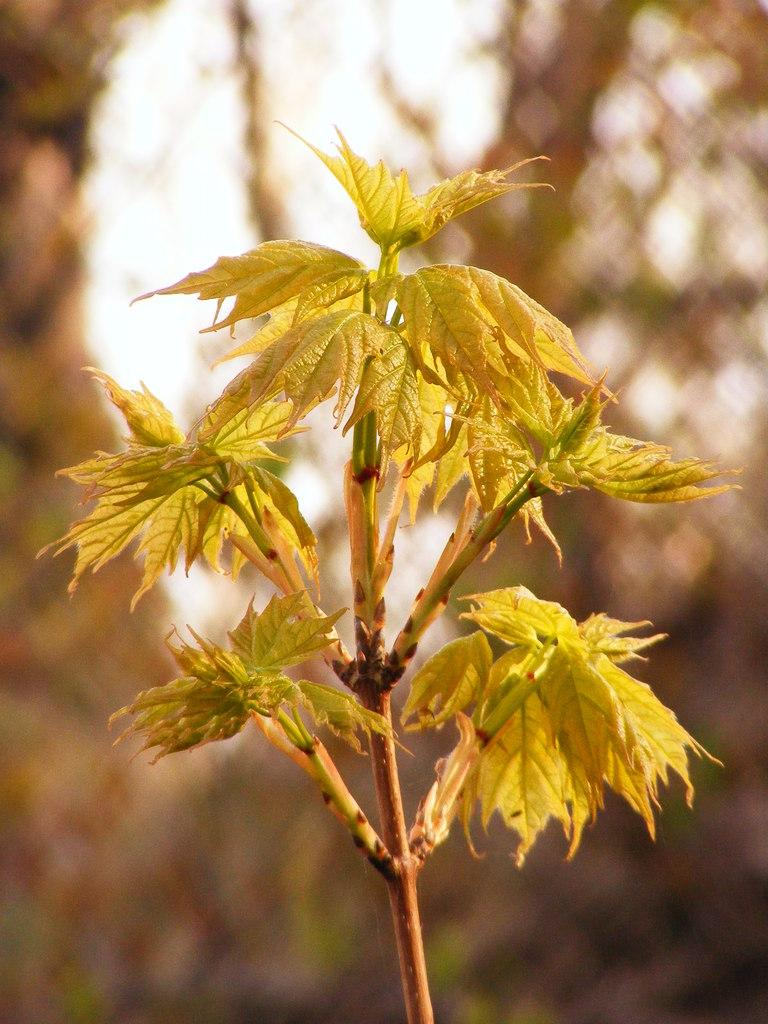What type of plant is visible in the image? There is a plant with green leaves in the image. What can be seen in the background of the image? There are trees and the sky visible in the background of the image. What type of bed is visible in the image? There is no bed present in the image; it features a plant with green leaves and trees in the background. 